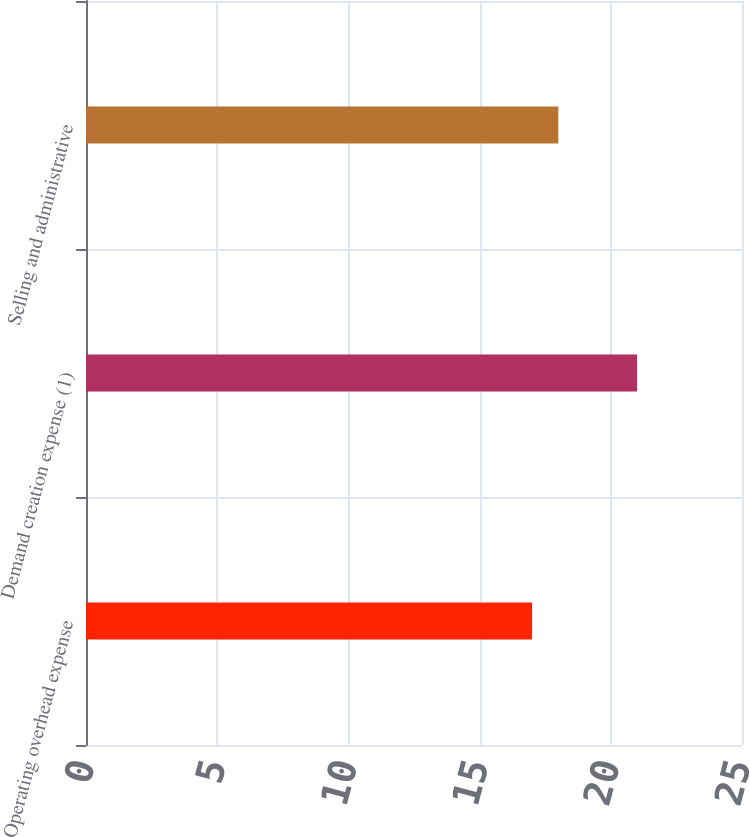<chart> <loc_0><loc_0><loc_500><loc_500><bar_chart><fcel>Operating overhead expense<fcel>Demand creation expense (1)<fcel>Selling and administrative<nl><fcel>17<fcel>21<fcel>18<nl></chart> 